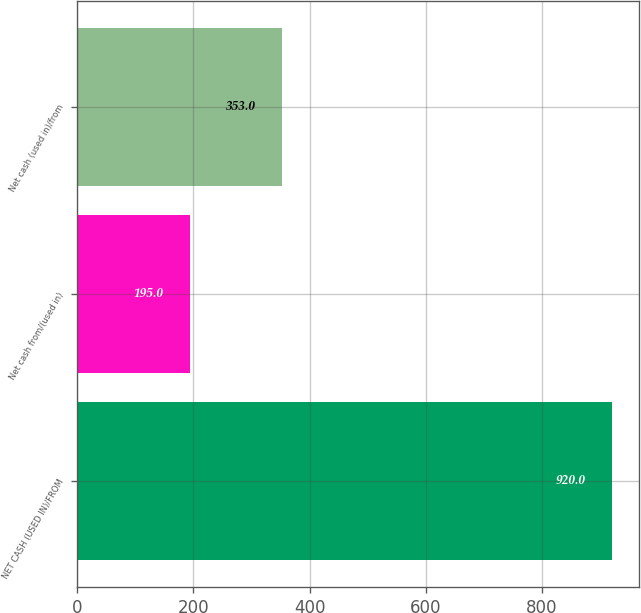Convert chart to OTSL. <chart><loc_0><loc_0><loc_500><loc_500><bar_chart><fcel>NET CASH (USED IN)/FROM<fcel>Net cash from/(used in)<fcel>Net cash (used in)/from<nl><fcel>920<fcel>195<fcel>353<nl></chart> 